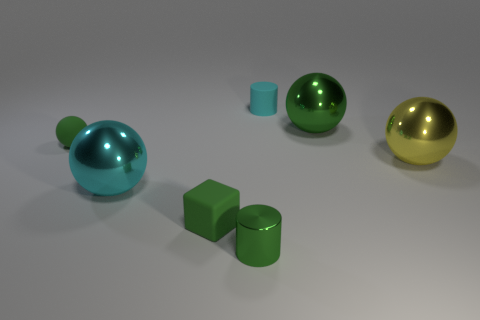There is a cube that is the same color as the metal cylinder; what is it made of?
Keep it short and to the point. Rubber. How many other things are the same color as the rubber block?
Provide a succinct answer. 3. What number of other things are the same shape as the small metal object?
Provide a succinct answer. 1. Is the green rubber ball the same size as the yellow sphere?
Ensure brevity in your answer.  No. Are any big gray rubber cylinders visible?
Offer a very short reply. No. Are there any large green balls that have the same material as the big cyan thing?
Give a very brief answer. Yes. There is a sphere that is the same size as the green rubber block; what is it made of?
Offer a terse response. Rubber. What number of big gray metal things have the same shape as the cyan matte object?
Make the answer very short. 0. What size is the yellow sphere that is made of the same material as the big green sphere?
Provide a succinct answer. Large. What material is the object that is both right of the small cube and to the left of the cyan matte cylinder?
Your answer should be very brief. Metal. 